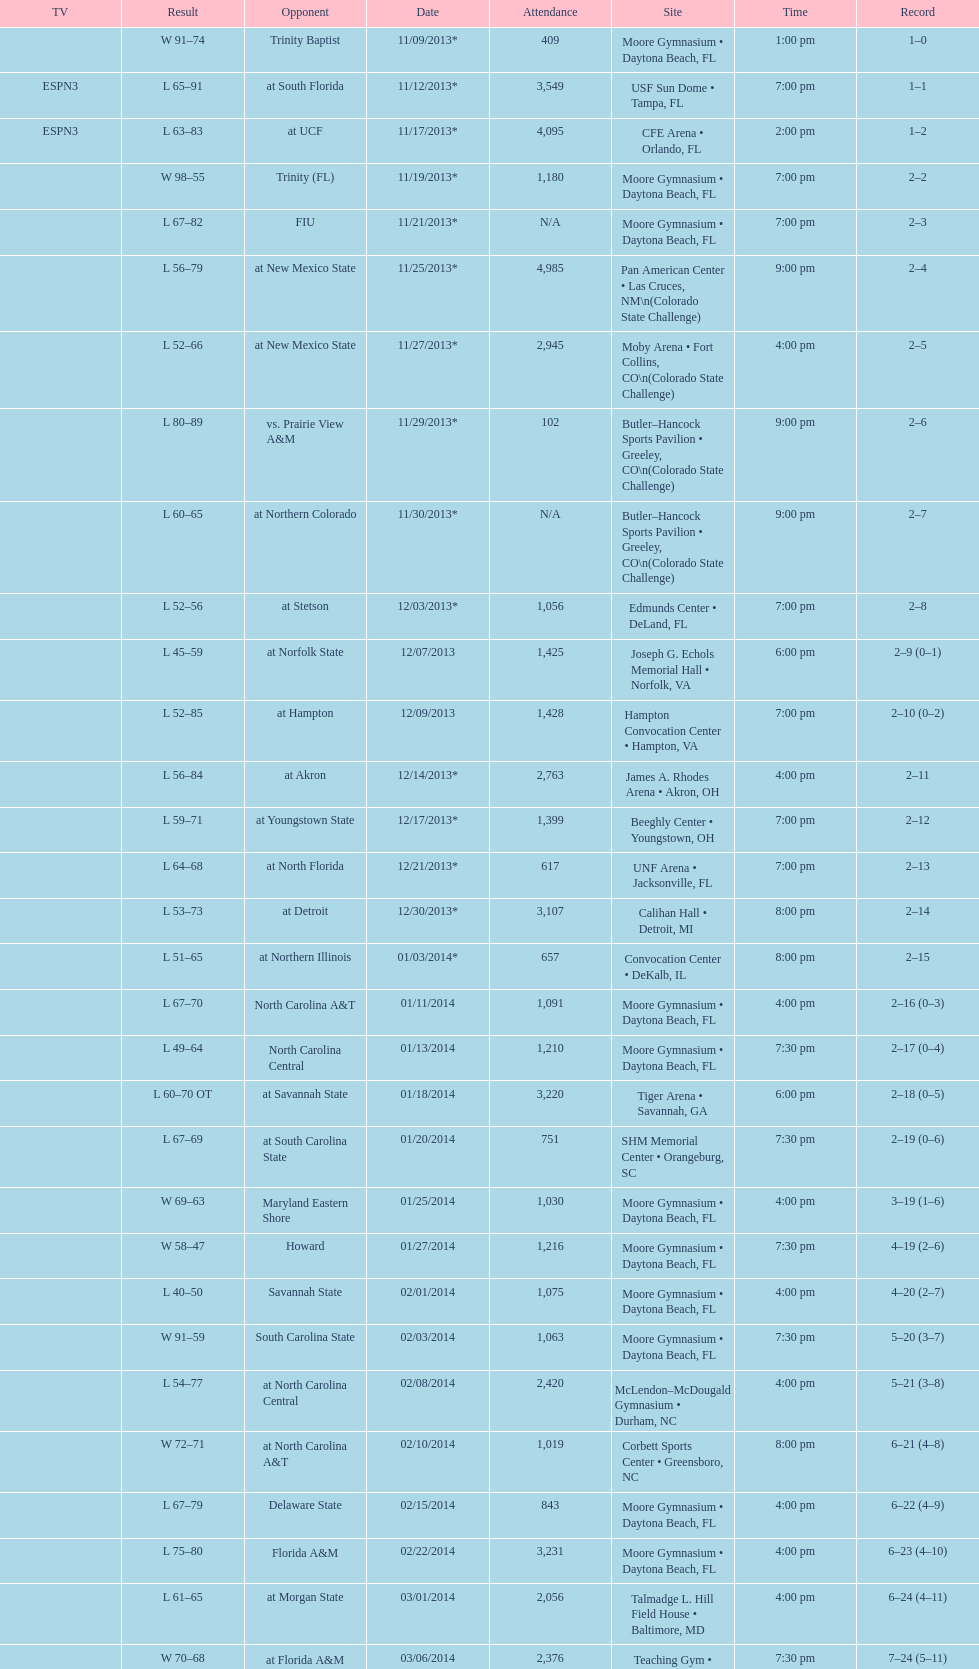By how many people was the attendance on 11/25/2013 greater than on 12/21/2013? 4368. 